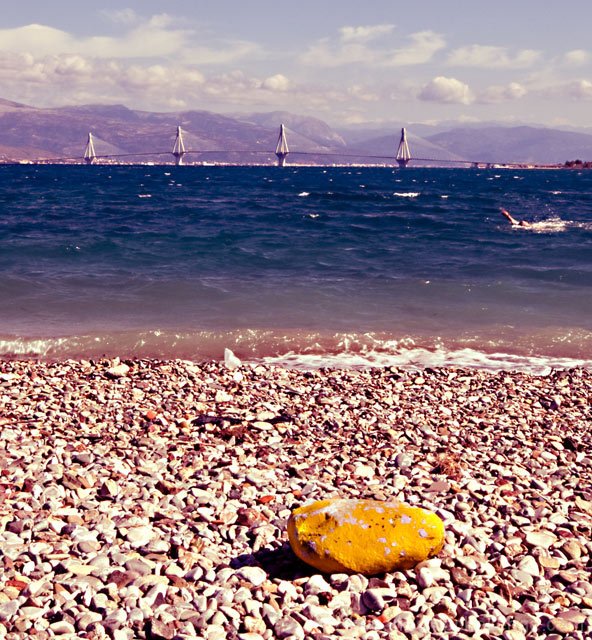What details can we observe about the location depicted in the image? This coastal scene suggests a pebble beach setting with a vibrant yellow rock as a focal point. There are several sailboats in the distance, indicating that this might be a popular area for sailing. The mountain range across the water adds a serene backdrop, suggesting the location could be along a sea or large lake, known for its sailing and picturesque landscapes. What time of day does it appear to be? Given the quality of the light and the shadows on the pebbles, it seems to be midday or early afternoon. The sunlight is bright, illuminating the scene vividly and casting minimal shadows. 